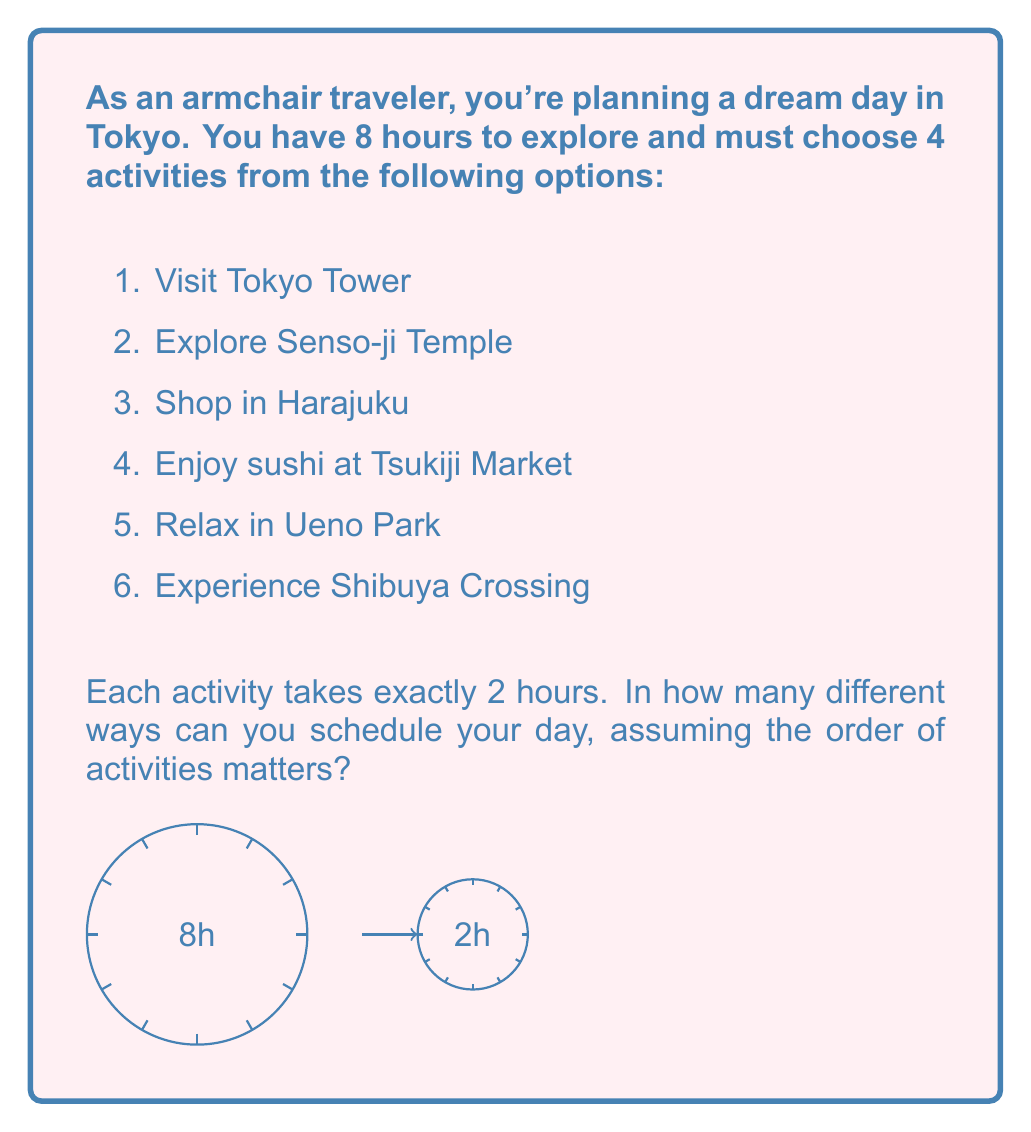Give your solution to this math problem. Let's approach this step-by-step:

1) We need to choose 4 activities out of 6 options, and the order matters. This is a permutation problem.

2) First, we calculate the number of ways to choose 4 activities out of 6:
   This is given by the combination formula: $\binom{6}{4} = \frac{6!}{4!(6-4)!} = \frac{6!}{4!2!}$

3) Calculate this:
   $$\binom{6}{4} = \frac{6 \cdot 5}{2 \cdot 1} = 15$$

4) Now, for each of these 15 choices, we need to consider the number of ways to arrange 4 activities.
   This is a straightforward permutation of 4 items: $P(4) = 4!$

5) Calculate this:
   $$4! = 4 \cdot 3 \cdot 2 \cdot 1 = 24$$

6) By the multiplication principle, the total number of ways to schedule the day is:
   Number of ways to choose 4 activities × Number of ways to arrange 4 activities
   $$15 \cdot 24 = 360$$

Therefore, there are 360 different ways to schedule your day in Tokyo.
Answer: 360 